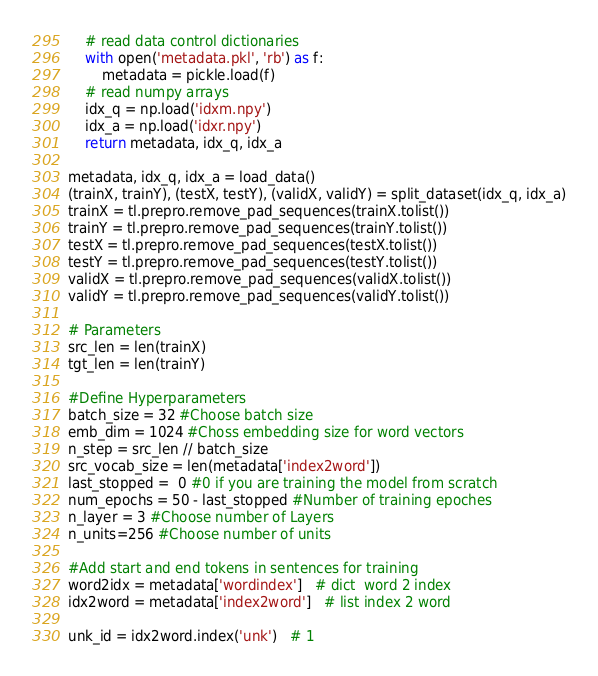<code> <loc_0><loc_0><loc_500><loc_500><_Python_>    # read data control dictionaries
    with open('metadata.pkl', 'rb') as f:
        metadata = pickle.load(f)
    # read numpy arrays
    idx_q = np.load('idxm.npy')
    idx_a = np.load('idxr.npy')
    return metadata, idx_q, idx_a

metadata, idx_q, idx_a = load_data()
(trainX, trainY), (testX, testY), (validX, validY) = split_dataset(idx_q, idx_a)
trainX = tl.prepro.remove_pad_sequences(trainX.tolist())
trainY = tl.prepro.remove_pad_sequences(trainY.tolist())
testX = tl.prepro.remove_pad_sequences(testX.tolist())
testY = tl.prepro.remove_pad_sequences(testY.tolist())
validX = tl.prepro.remove_pad_sequences(validX.tolist())
validY = tl.prepro.remove_pad_sequences(validY.tolist())

# Parameters
src_len = len(trainX)
tgt_len = len(trainY)

#Define Hyperparameters
batch_size = 32 #Choose batch size
emb_dim = 1024 #Choss embedding size for word vectors
n_step = src_len // batch_size
src_vocab_size = len(metadata['index2word'])
last_stopped =  0 #0 if you are training the model from scratch
num_epochs = 50 - last_stopped #Number of training epoches
n_layer = 3 #Choose number of Layers
n_units=256 #Choose number of units

#Add start and end tokens in sentences for training
word2idx = metadata['wordindex']   # dict  word 2 index
idx2word = metadata['index2word']   # list index 2 word

unk_id = idx2word.index('unk')   # 1</code> 